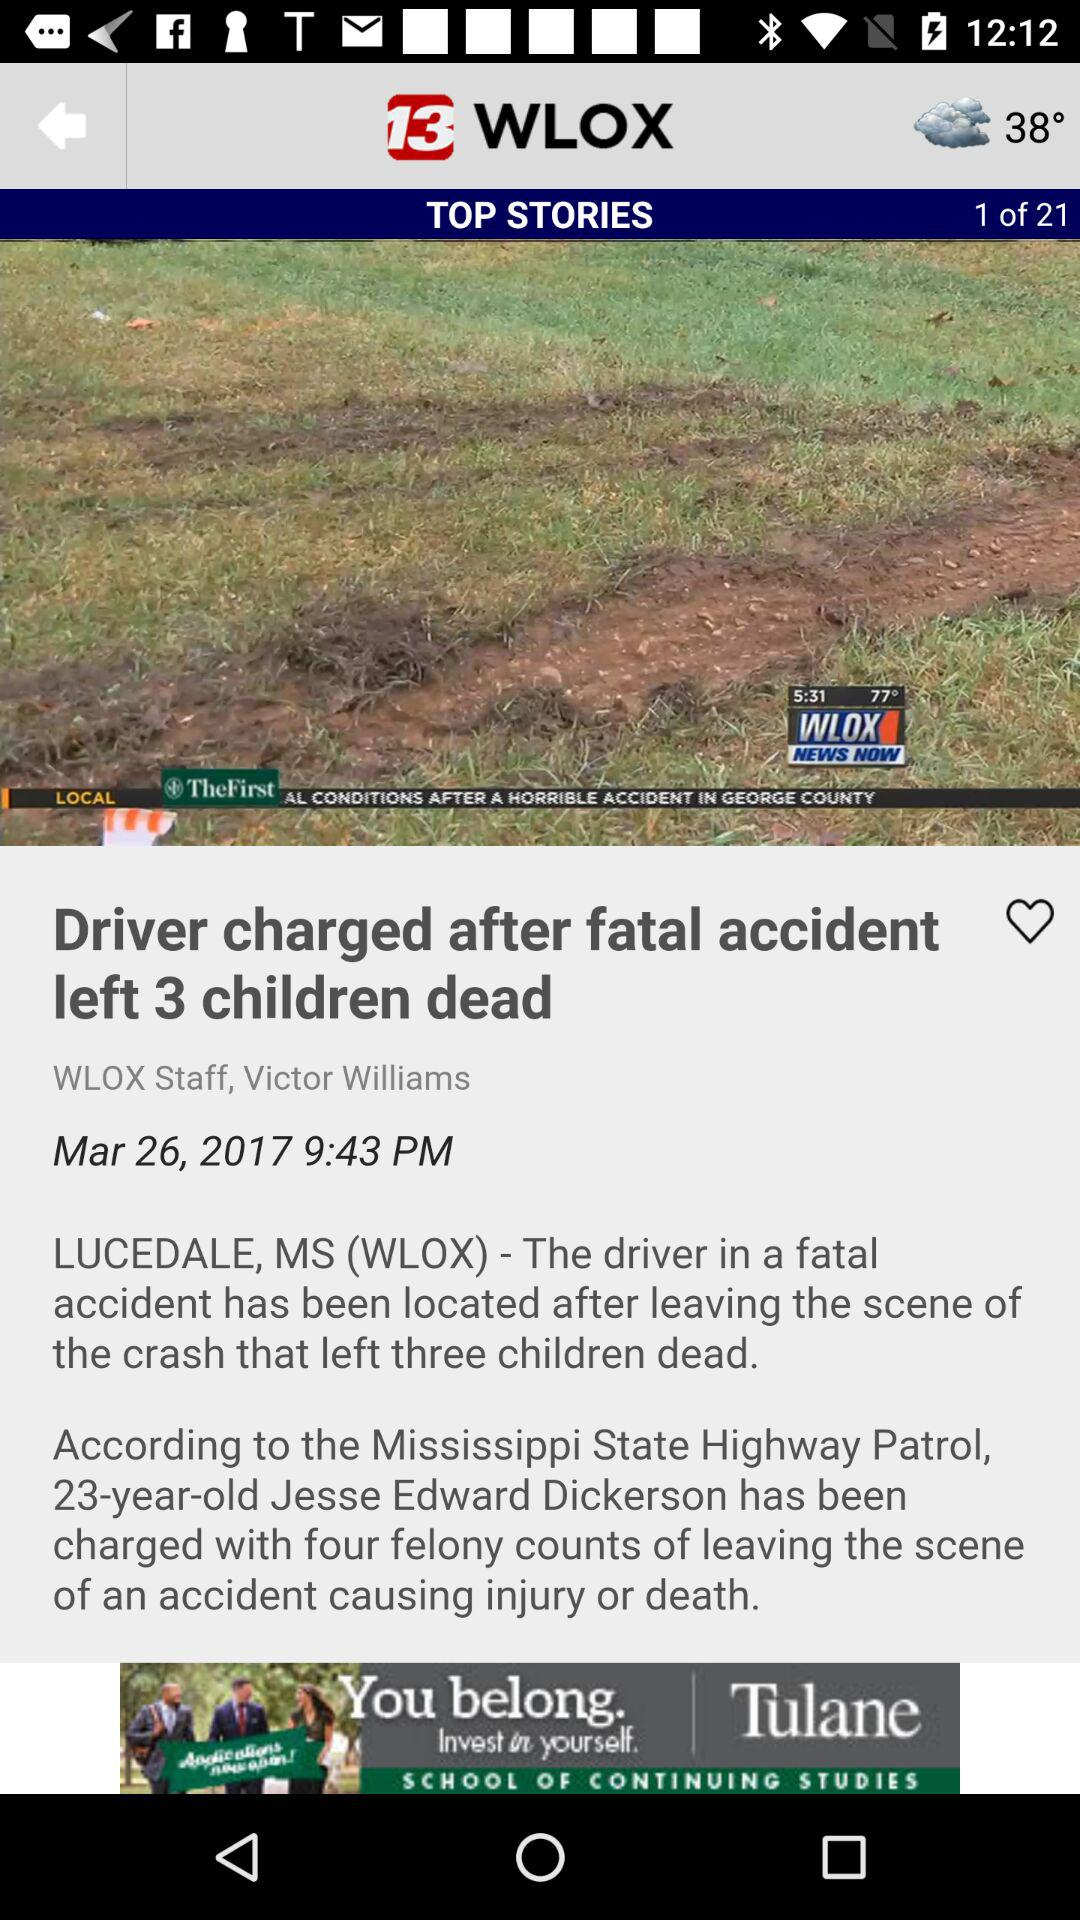What is the current story number in "TOP STORIES"? The current story number in "TOP STORIES" is 1. 